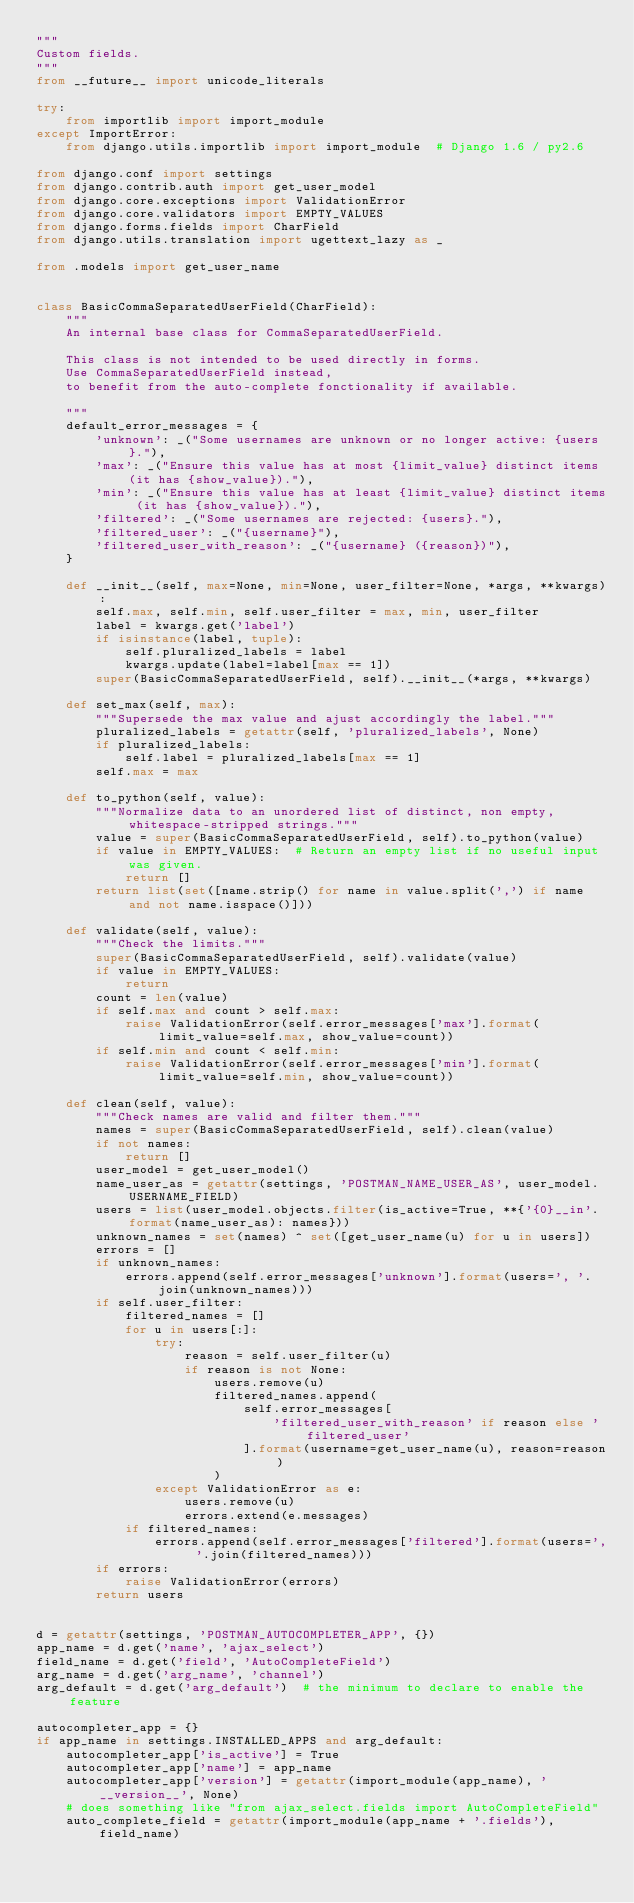Convert code to text. <code><loc_0><loc_0><loc_500><loc_500><_Python_>"""
Custom fields.
"""
from __future__ import unicode_literals

try:
    from importlib import import_module
except ImportError:
    from django.utils.importlib import import_module  # Django 1.6 / py2.6

from django.conf import settings
from django.contrib.auth import get_user_model
from django.core.exceptions import ValidationError
from django.core.validators import EMPTY_VALUES
from django.forms.fields import CharField
from django.utils.translation import ugettext_lazy as _

from .models import get_user_name


class BasicCommaSeparatedUserField(CharField):
    """
    An internal base class for CommaSeparatedUserField.

    This class is not intended to be used directly in forms.
    Use CommaSeparatedUserField instead,
    to benefit from the auto-complete fonctionality if available.

    """
    default_error_messages = {
        'unknown': _("Some usernames are unknown or no longer active: {users}."),
        'max': _("Ensure this value has at most {limit_value} distinct items (it has {show_value})."),
        'min': _("Ensure this value has at least {limit_value} distinct items (it has {show_value})."),
        'filtered': _("Some usernames are rejected: {users}."),
        'filtered_user': _("{username}"),
        'filtered_user_with_reason': _("{username} ({reason})"),
    }

    def __init__(self, max=None, min=None, user_filter=None, *args, **kwargs):
        self.max, self.min, self.user_filter = max, min, user_filter
        label = kwargs.get('label')
        if isinstance(label, tuple):
            self.pluralized_labels = label
            kwargs.update(label=label[max == 1])
        super(BasicCommaSeparatedUserField, self).__init__(*args, **kwargs)

    def set_max(self, max):
        """Supersede the max value and ajust accordingly the label."""
        pluralized_labels = getattr(self, 'pluralized_labels', None)
        if pluralized_labels:
            self.label = pluralized_labels[max == 1]
        self.max = max

    def to_python(self, value):
        """Normalize data to an unordered list of distinct, non empty, whitespace-stripped strings."""
        value = super(BasicCommaSeparatedUserField, self).to_python(value)
        if value in EMPTY_VALUES:  # Return an empty list if no useful input was given.
            return []
        return list(set([name.strip() for name in value.split(',') if name and not name.isspace()]))

    def validate(self, value):
        """Check the limits."""
        super(BasicCommaSeparatedUserField, self).validate(value)
        if value in EMPTY_VALUES:
            return
        count = len(value)
        if self.max and count > self.max:
            raise ValidationError(self.error_messages['max'].format(limit_value=self.max, show_value=count))
        if self.min and count < self.min:
            raise ValidationError(self.error_messages['min'].format(limit_value=self.min, show_value=count))

    def clean(self, value):
        """Check names are valid and filter them."""
        names = super(BasicCommaSeparatedUserField, self).clean(value)
        if not names:
            return []
        user_model = get_user_model()
        name_user_as = getattr(settings, 'POSTMAN_NAME_USER_AS', user_model.USERNAME_FIELD)
        users = list(user_model.objects.filter(is_active=True, **{'{0}__in'.format(name_user_as): names}))
        unknown_names = set(names) ^ set([get_user_name(u) for u in users])
        errors = []
        if unknown_names:
            errors.append(self.error_messages['unknown'].format(users=', '.join(unknown_names)))
        if self.user_filter:
            filtered_names = []
            for u in users[:]:
                try:
                    reason = self.user_filter(u)
                    if reason is not None:
                        users.remove(u)
                        filtered_names.append(
                            self.error_messages[
                                'filtered_user_with_reason' if reason else 'filtered_user'
                            ].format(username=get_user_name(u), reason=reason)
                        )
                except ValidationError as e:
                    users.remove(u)
                    errors.extend(e.messages)
            if filtered_names:
                errors.append(self.error_messages['filtered'].format(users=', '.join(filtered_names)))
        if errors:
            raise ValidationError(errors)
        return users


d = getattr(settings, 'POSTMAN_AUTOCOMPLETER_APP', {})
app_name = d.get('name', 'ajax_select')
field_name = d.get('field', 'AutoCompleteField')
arg_name = d.get('arg_name', 'channel')
arg_default = d.get('arg_default')  # the minimum to declare to enable the feature

autocompleter_app = {}
if app_name in settings.INSTALLED_APPS and arg_default:
    autocompleter_app['is_active'] = True
    autocompleter_app['name'] = app_name
    autocompleter_app['version'] = getattr(import_module(app_name), '__version__', None)
    # does something like "from ajax_select.fields import AutoCompleteField"
    auto_complete_field = getattr(import_module(app_name + '.fields'), field_name)

</code> 